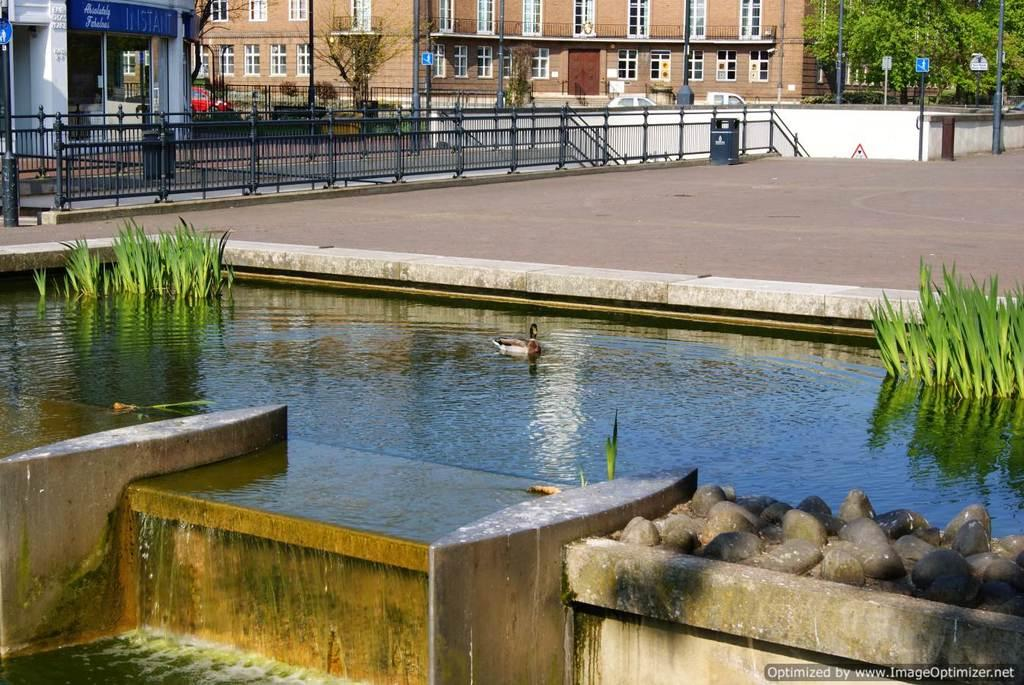What is located in the center of the image? There is water, plants, and a bird in the center of the image. What can be seen in the background of the image? There are trees, buildings, windows, poles, fences, sign boards, and vehicles in the background of the image. What type of food is the bird eating in the image? There is no food visible in the image, and the bird's actions are not described. How many arms can be seen reaching out from the water in the image? There are no arms present in the image; it features water, plants, and a bird in the center. 